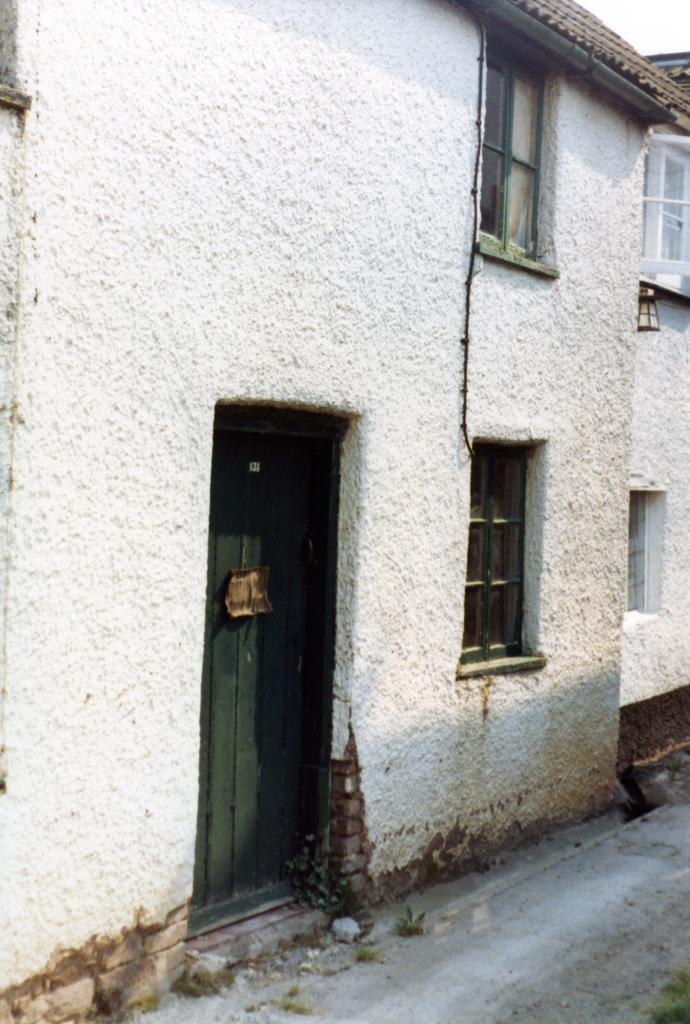Please provide a concise description of this image. In this image we can see houses, doors, windows. At the bottom of the image there is road. 